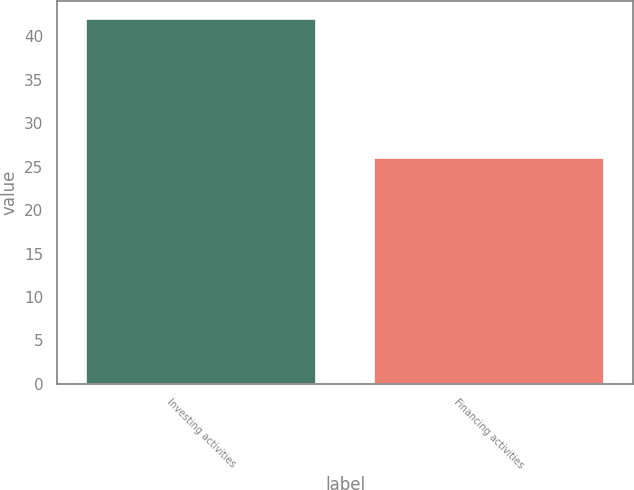<chart> <loc_0><loc_0><loc_500><loc_500><bar_chart><fcel>Investing activities<fcel>Financing activities<nl><fcel>42<fcel>26<nl></chart> 